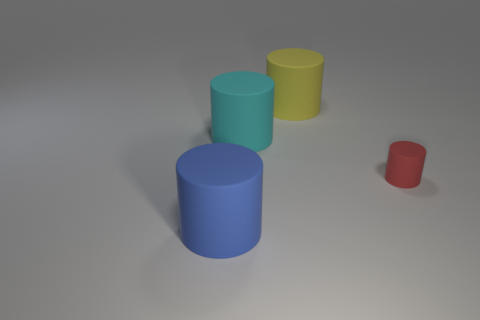Subtract all big cyan cylinders. How many cylinders are left? 3 Add 2 yellow metal blocks. How many objects exist? 6 Subtract all cyan cylinders. How many cylinders are left? 3 Subtract 1 cylinders. How many cylinders are left? 3 Add 2 small matte cylinders. How many small matte cylinders are left? 3 Add 3 small cylinders. How many small cylinders exist? 4 Subtract 0 cyan balls. How many objects are left? 4 Subtract all red cylinders. Subtract all yellow balls. How many cylinders are left? 3 Subtract all cyan blocks. How many yellow cylinders are left? 1 Subtract all tiny green metallic cubes. Subtract all yellow objects. How many objects are left? 3 